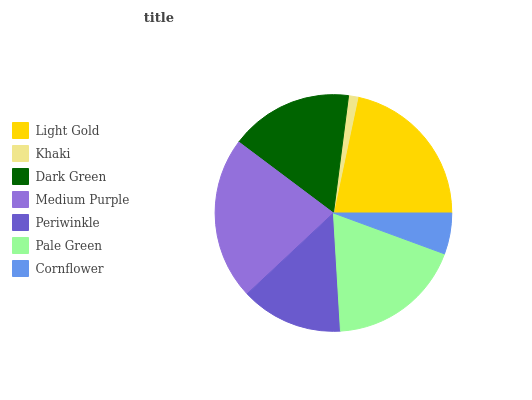Is Khaki the minimum?
Answer yes or no. Yes. Is Medium Purple the maximum?
Answer yes or no. Yes. Is Dark Green the minimum?
Answer yes or no. No. Is Dark Green the maximum?
Answer yes or no. No. Is Dark Green greater than Khaki?
Answer yes or no. Yes. Is Khaki less than Dark Green?
Answer yes or no. Yes. Is Khaki greater than Dark Green?
Answer yes or no. No. Is Dark Green less than Khaki?
Answer yes or no. No. Is Dark Green the high median?
Answer yes or no. Yes. Is Dark Green the low median?
Answer yes or no. Yes. Is Light Gold the high median?
Answer yes or no. No. Is Light Gold the low median?
Answer yes or no. No. 